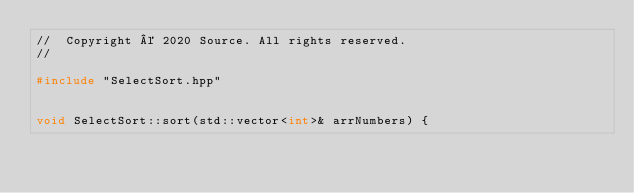Convert code to text. <code><loc_0><loc_0><loc_500><loc_500><_C++_>//  Copyright © 2020 Source. All rights reserved.
//

#include "SelectSort.hpp"


void SelectSort::sort(std::vector<int>& arrNumbers) {
    </code> 